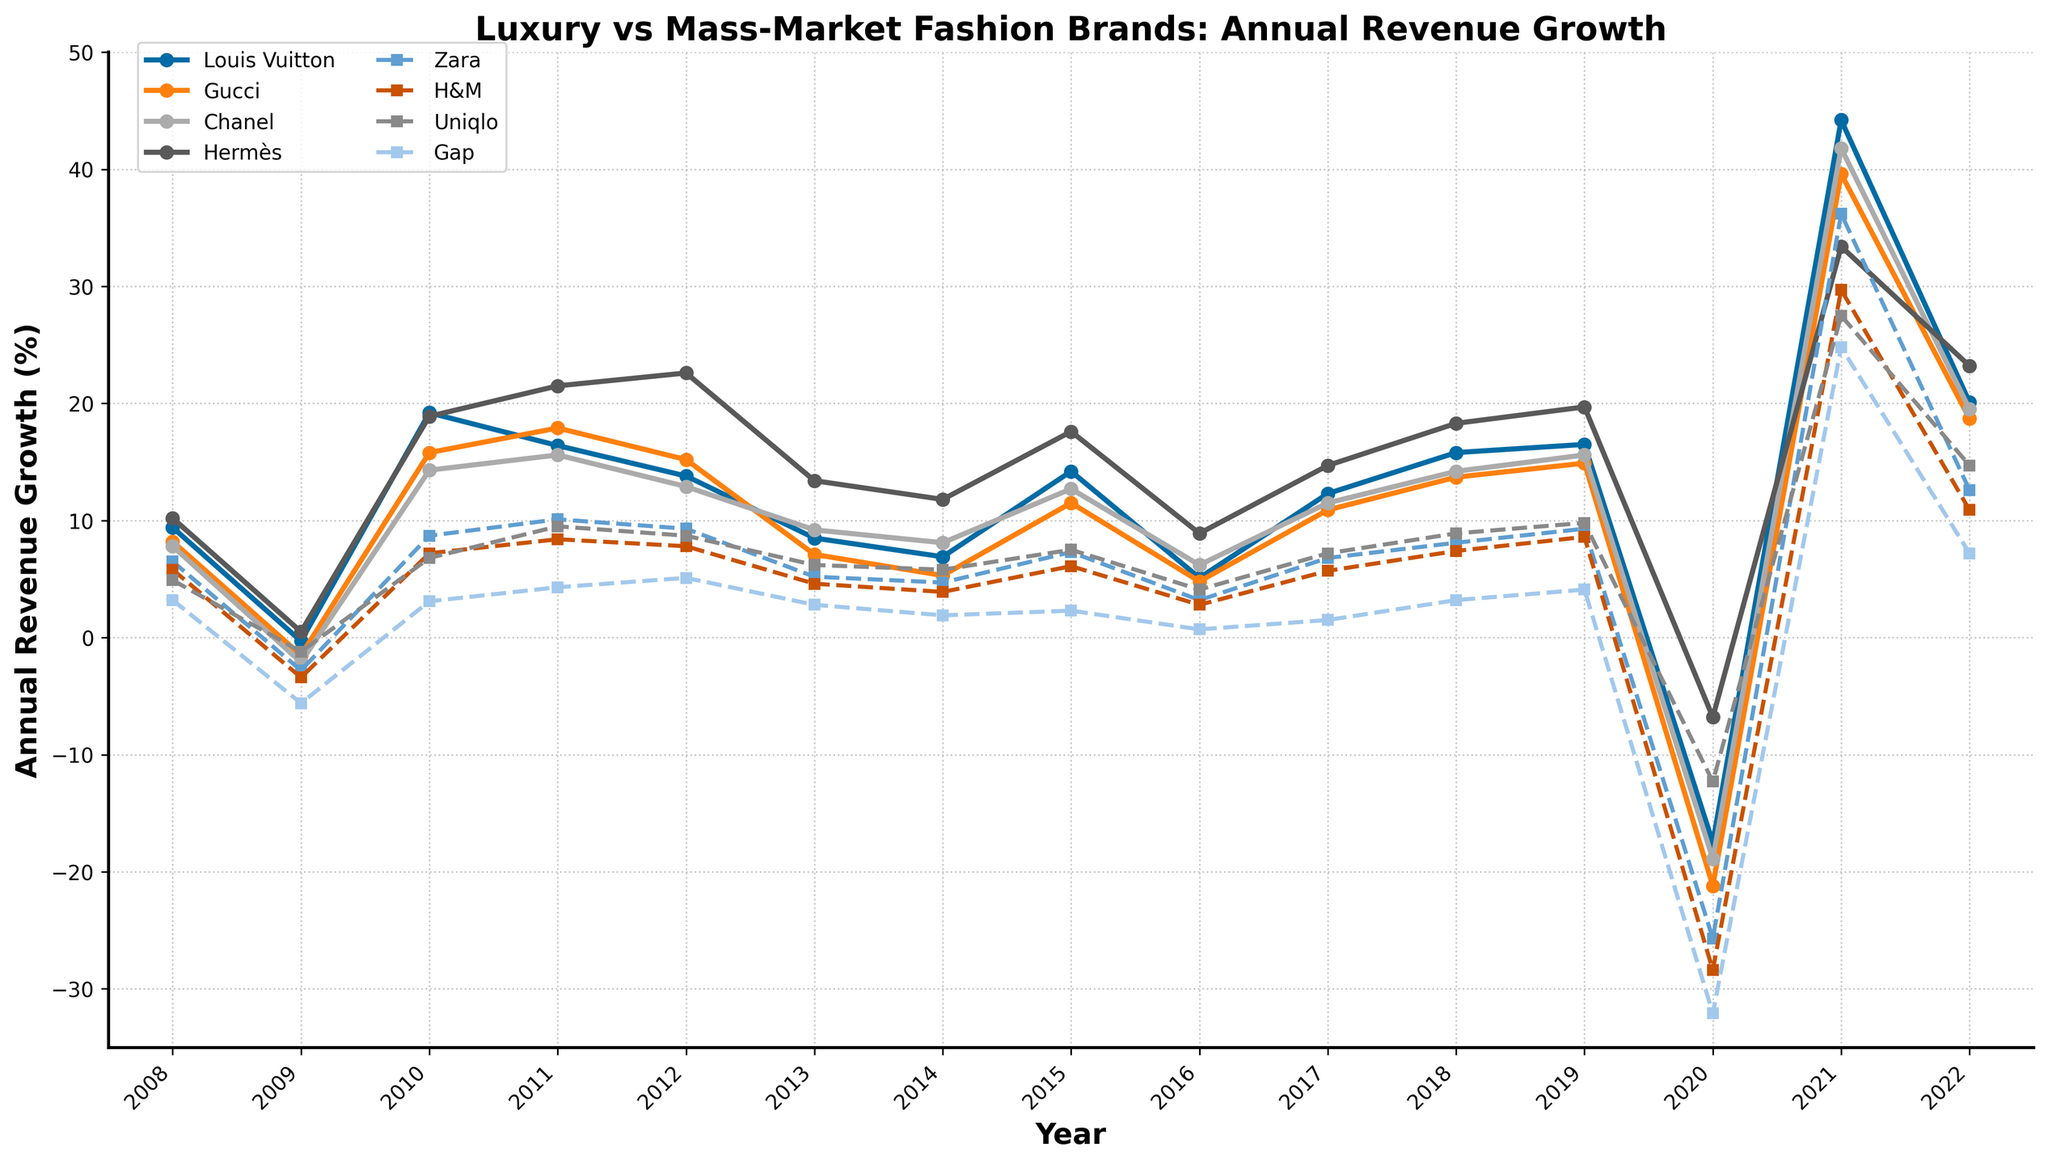Which brand experienced the highest revenue growth in 2021? To determine the highest revenue growth in 2021, observe the points on the line chart for the year 2021 and compare the values. Louis Vuitton has the highest point among all others.
Answer: Louis Vuitton Which brand had consistent growth in revenue from 2008 to 2015 without any decline? Look for any brand whose line on the chart consistently rises without dips between 2008 and 2015. Hermès shows steady growth without any dips during this period.
Answer: Hermès What was the revenue growth rate for Uniqlo in 2020, and how does it compare to its rate in 2021? Check the points on Uniqlo’s line for the years 2020 and 2021. In 2020, the value is -12.3%, and in 2021, the value is 27.5%.
Answer: -12.3% in 2020 vs. 27.5% in 2021 Which luxury brand had the smallest average annual revenue growth from 2008 to 2019? Calculate the average annual growth for each luxury brand from 2008 to 2019. Compare these averages to identify the smallest one. Chanel has consistently lower points than others over many years.
Answer: Chanel What is the difference in revenue growth between Hermes and Zara in 2022? Find the points for Hermes and Zara in 2022 and note their values. Subtract Zara’s value (12.6%) from Hermes’ value (23.2%).
Answer: 10.6% Which mass-market brand had the largest decline in revenue in 2020? Inspect the points for all mass-market brands in 2020. The lowest point among Zara, H&M, Uniqlo, and Gap indicates the largest decline. Gap has the lowest point at -32.1%.
Answer: Gap How does the revenue growth trend of Louis Vuitton compare to Uniqlo from 2008 to 2022? Compare the general direction and shape of Louis Vuitton's and Uniqlo’s lines from 2008 to 2022. Louis Vuitton shows more steady and higher growth with occasional dips, whereas Uniqlo has more fluctuations and lower overall growth.
Answer: Louis Vuitton more stable and higher, Uniqlo more fluctuating What was the relative revenue growth of Gucci compared to H&M in 2009? Look at the points for Gucci and H&M in 2009. Calculate their difference by subtracting H&M's value (-3.4%) from Gucci’s value (-1.5%).
Answer: 1.9% higher Which year had the sharpest drop for luxury brands collectively? Identify the year with the most negative points for luxury brands collectively. In 2020, all luxury brands show sharp declines, indicating the largest collective drop.
Answer: 2020 Which mass-market brand had the most significant recovery in revenue growth from 2020 to 2021? Analyze the points for each mass-market brand in 2020 and 2021. Calculate the rise for each. H&M has the largest change from -28.4% in 2020 to 29.7% in 2021.
Answer: H&M 